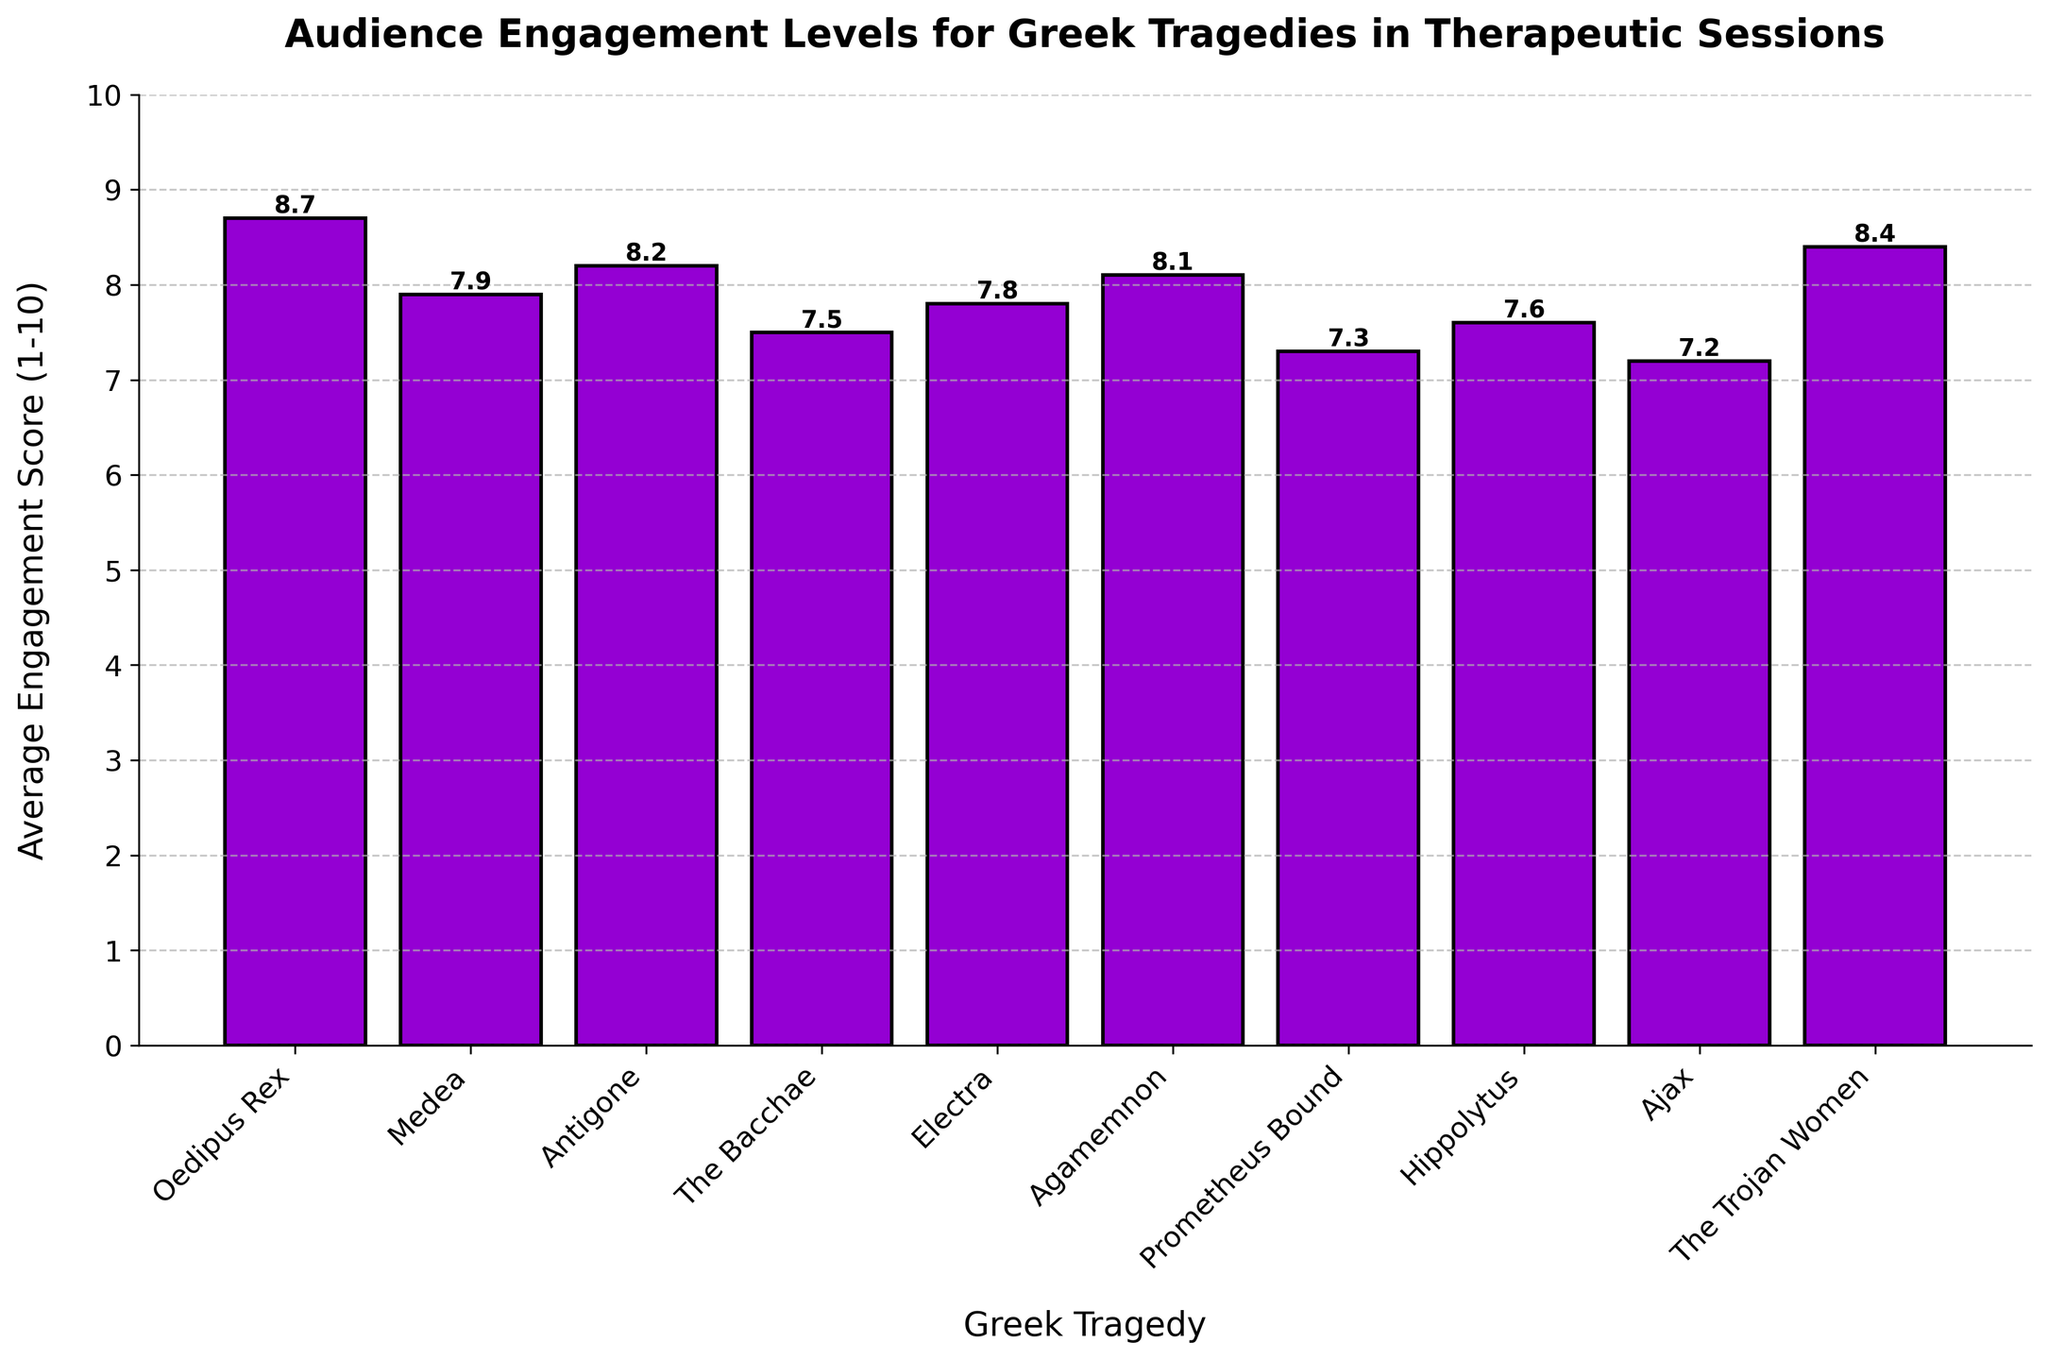Which Greek tragedy has the highest audience engagement score? To answer this question, look for the tallest bar in the bar chart. The tragedy at the top of that bar has the highest engagement score.
Answer: Oedipus Rex What is the difference in engagement scores between 'The Bacchae' and 'Agamemnon'? Find the heights of the bars for 'The Bacchae' (7.5) and 'Agamemnon' (8.1). Subtract the score of 'The Bacchae' from 'Agamemnon'. Calculation: 8.1 - 7.5 = 0.6
Answer: 0.6 Which tragedy has a higher average engagement score, 'Medea' or 'The Trojan Women'? Compare the heights of the bars for 'Medea' (7.9) and 'The Trojan Women' (8.4). 'The Trojan Women' is higher.
Answer: The Trojan Women Out of the tragedies with engagement scores above 8, which has the lowest engagement score? Identify the bars with scores above 8. They are 'Oedipus Rex' (8.7), 'Antigone' (8.2), 'Agamemnon' (8.1), and 'The Trojan Women' (8.4). The lowest among these is 'Agamemnon'.
Answer: Agamemnon What is the average engagement score of 'Electra', 'Hippolytus', and 'Ajax'? Find the scores for 'Electra' (7.8), 'Hippolytus' (7.6), and 'Ajax' (7.2). Calculate their average: (7.8 + 7.6 + 7.2) / 3 = 7.53
Answer: 7.53 How many Greek tragedies have an average engagement score above 8? Count the bars with scores above 8: 'Oedipus Rex' (8.7), 'Antigone' (8.2), 'The Trojan Women' (8.4), and 'Agamemnon' (8.1). There are 4 such tragedies.
Answer: 4 Which tragedy has a lower engagement score, 'Prometheus Bound' or 'Ajax'? Compare the heights of the bars for 'Prometheus Bound' (7.3) and 'Ajax' (7.2). 'Ajax' is slightly lower.
Answer: Ajax What is the sum of the engagement scores for 'Medea', 'Electra', and 'Hippolytus'? Find the scores for 'Medea' (7.9), 'Electra' (7.8), and 'Hippolytus' (7.6). Calculate their sum: 7.9 + 7.8 + 7.6 = 23.3
Answer: 23.3 What is the visual color of the bars representing the engagement scores? The bars representing the engagement scores are colored in dark violet.
Answer: dark violet What range of engagement scores can be observed in the bar chart (minimum and maximum values)? Identify the shortest and tallest bars to find the range. The shortest bar is 'Ajax' (7.2) and the tallest is 'Oedipus Rex' (8.7). The range is from 7.2 to 8.7.
Answer: 7.2 to 8.7 